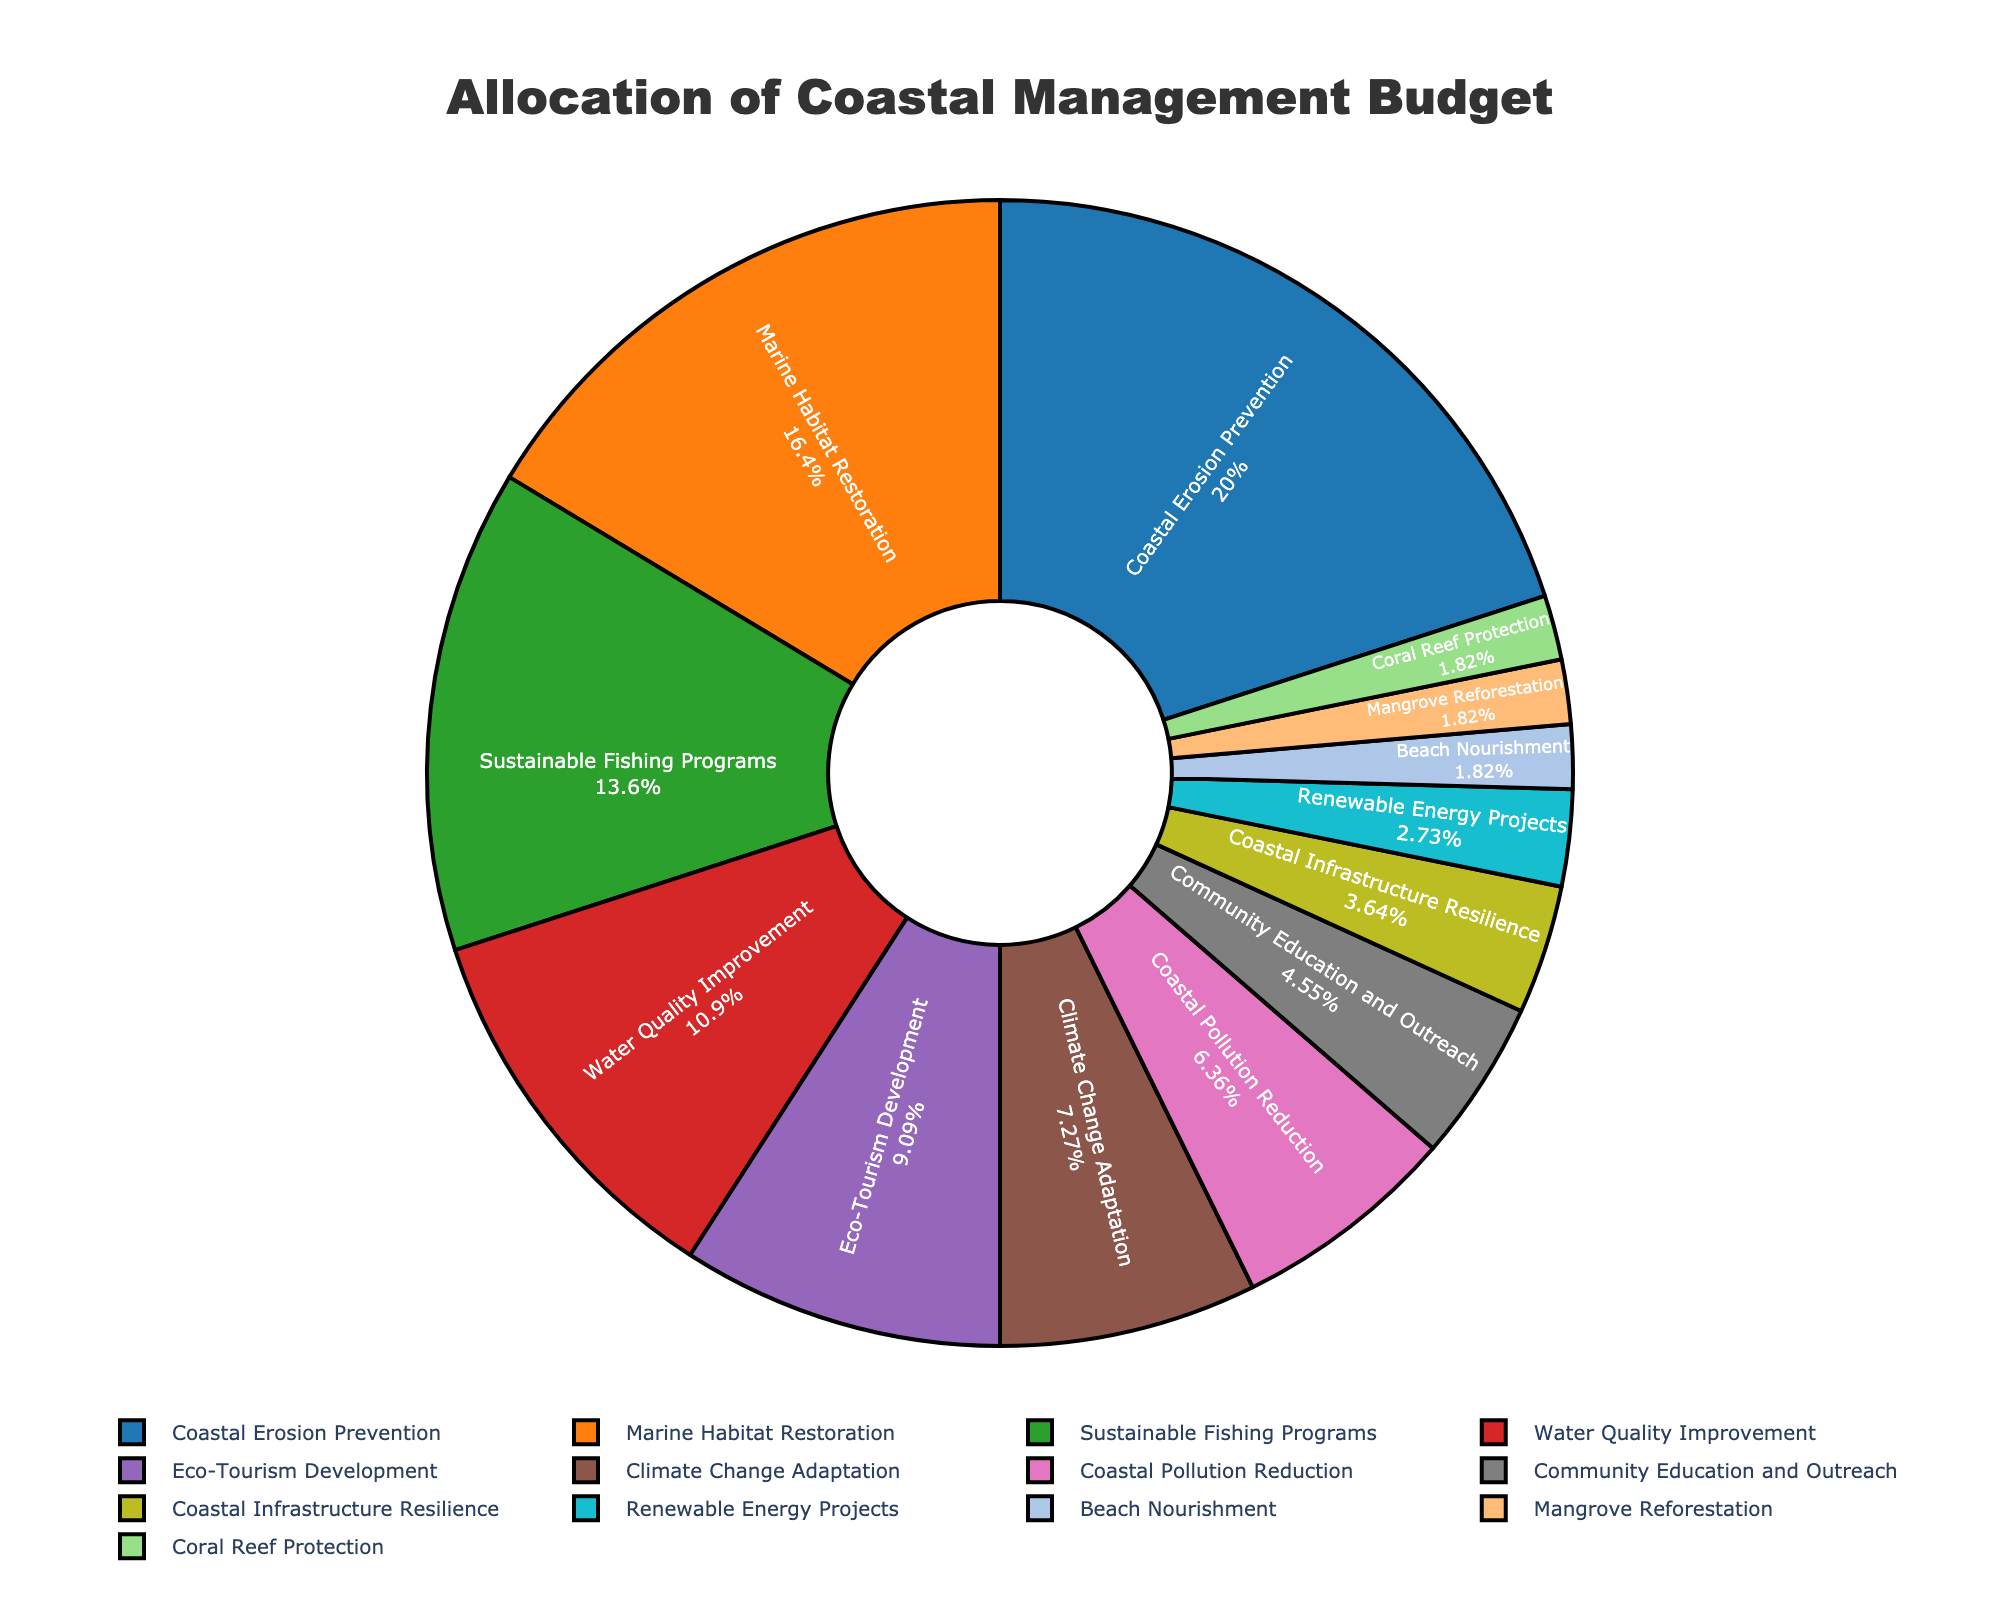How much of the budget is allocated to both "Coastal Erosion Prevention" and "Marine Habitat Restoration" combined? Sum the percentages allocated to "Coastal Erosion Prevention" (22%) and "Marine Habitat Restoration" (18%). Therefore, 22 + 18 = 40.
Answer: 40% Which initiative receives a higher budget percentage: "Sustainable Fishing Programs" or "Water Quality Improvement"? Compare the budget percentages for "Sustainable Fishing Programs" (15%) and "Water Quality Improvement" (12%). Since 15 is greater than 12, "Sustainable Fishing Programs" receives a higher allocation.
Answer: Sustainable Fishing Programs What is the total percentage allocated to the three initiatives with the smallest budget? Sum the percentages for "Renewable Energy Projects" (3%), "Beach Nourishment" (2%), "Mangrove Reforestation" (2%), and "Coral Reef Protection" (2%). Therefore, 3 + 2 + 2 + 2 = 9.
Answer: 9% Which initiative is represented by the darkest segment in the pie chart? Identify the darkest color in the pie chart and correlate it with the initiative label. The darkest segment corresponds to the color representing "Coastal Erosion Prevention."
Answer: Coastal Erosion Prevention What is the difference in budget allocation between "Climate Change Adaptation" and "Coastal Pollution Reduction"? Subtract the budget percentage of "Coastal Pollution Reduction" (7%) from "Climate Change Adaptation" (8%). Therefore, 8 - 7 = 1.
Answer: 1% How many initiatives have a budget allocation of less than 5%? Count the initiatives with budget percentages less than 5%. These are "Coastal Infrastructure Resilience" (4%), "Renewable Energy Projects" (3%), "Beach Nourishment" (2%), "Mangrove Reforestation" (2%), and "Coral Reef Protection" (2%). There are 5 in total.
Answer: 5 What visual cue is used to indicate the relative size of the budget allocations in the pie chart? Identify the visual attributes used in the pie chart. The relative size of the budget allocations is represented by the size of each segment in the pie chart.
Answer: Segment size Among the largest and smallest budget allocations, what is the ratio of "Coastal Erosion Prevention" to "Mangrove Reforestation"? Find the budget percentages for "Coastal Erosion Prevention" (22%) and "Mangrove Reforestation" (2%) and calculate the ratio 22:2, which simplifies to 11:1.
Answer: 11:1 